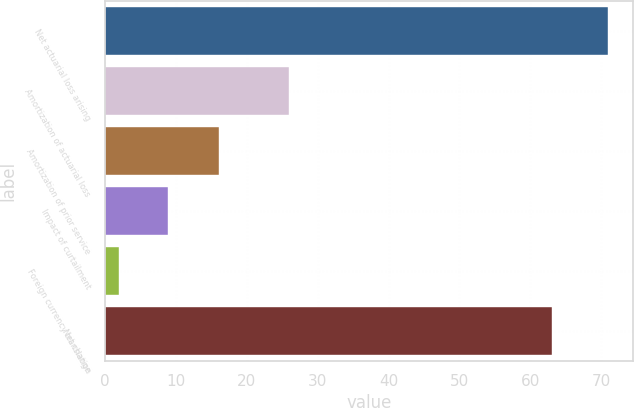Convert chart. <chart><loc_0><loc_0><loc_500><loc_500><bar_chart><fcel>Net actuarial loss arising<fcel>Amortization of actuarial loss<fcel>Amortization of prior service<fcel>Impact of curtailment<fcel>Foreign currency translation<fcel>Net change<nl><fcel>71<fcel>26<fcel>16<fcel>8.9<fcel>2<fcel>63<nl></chart> 